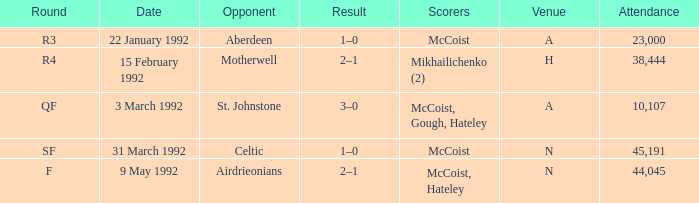What is the result with an attendance larger than 10,107 and Celtic as the opponent? 1–0. 